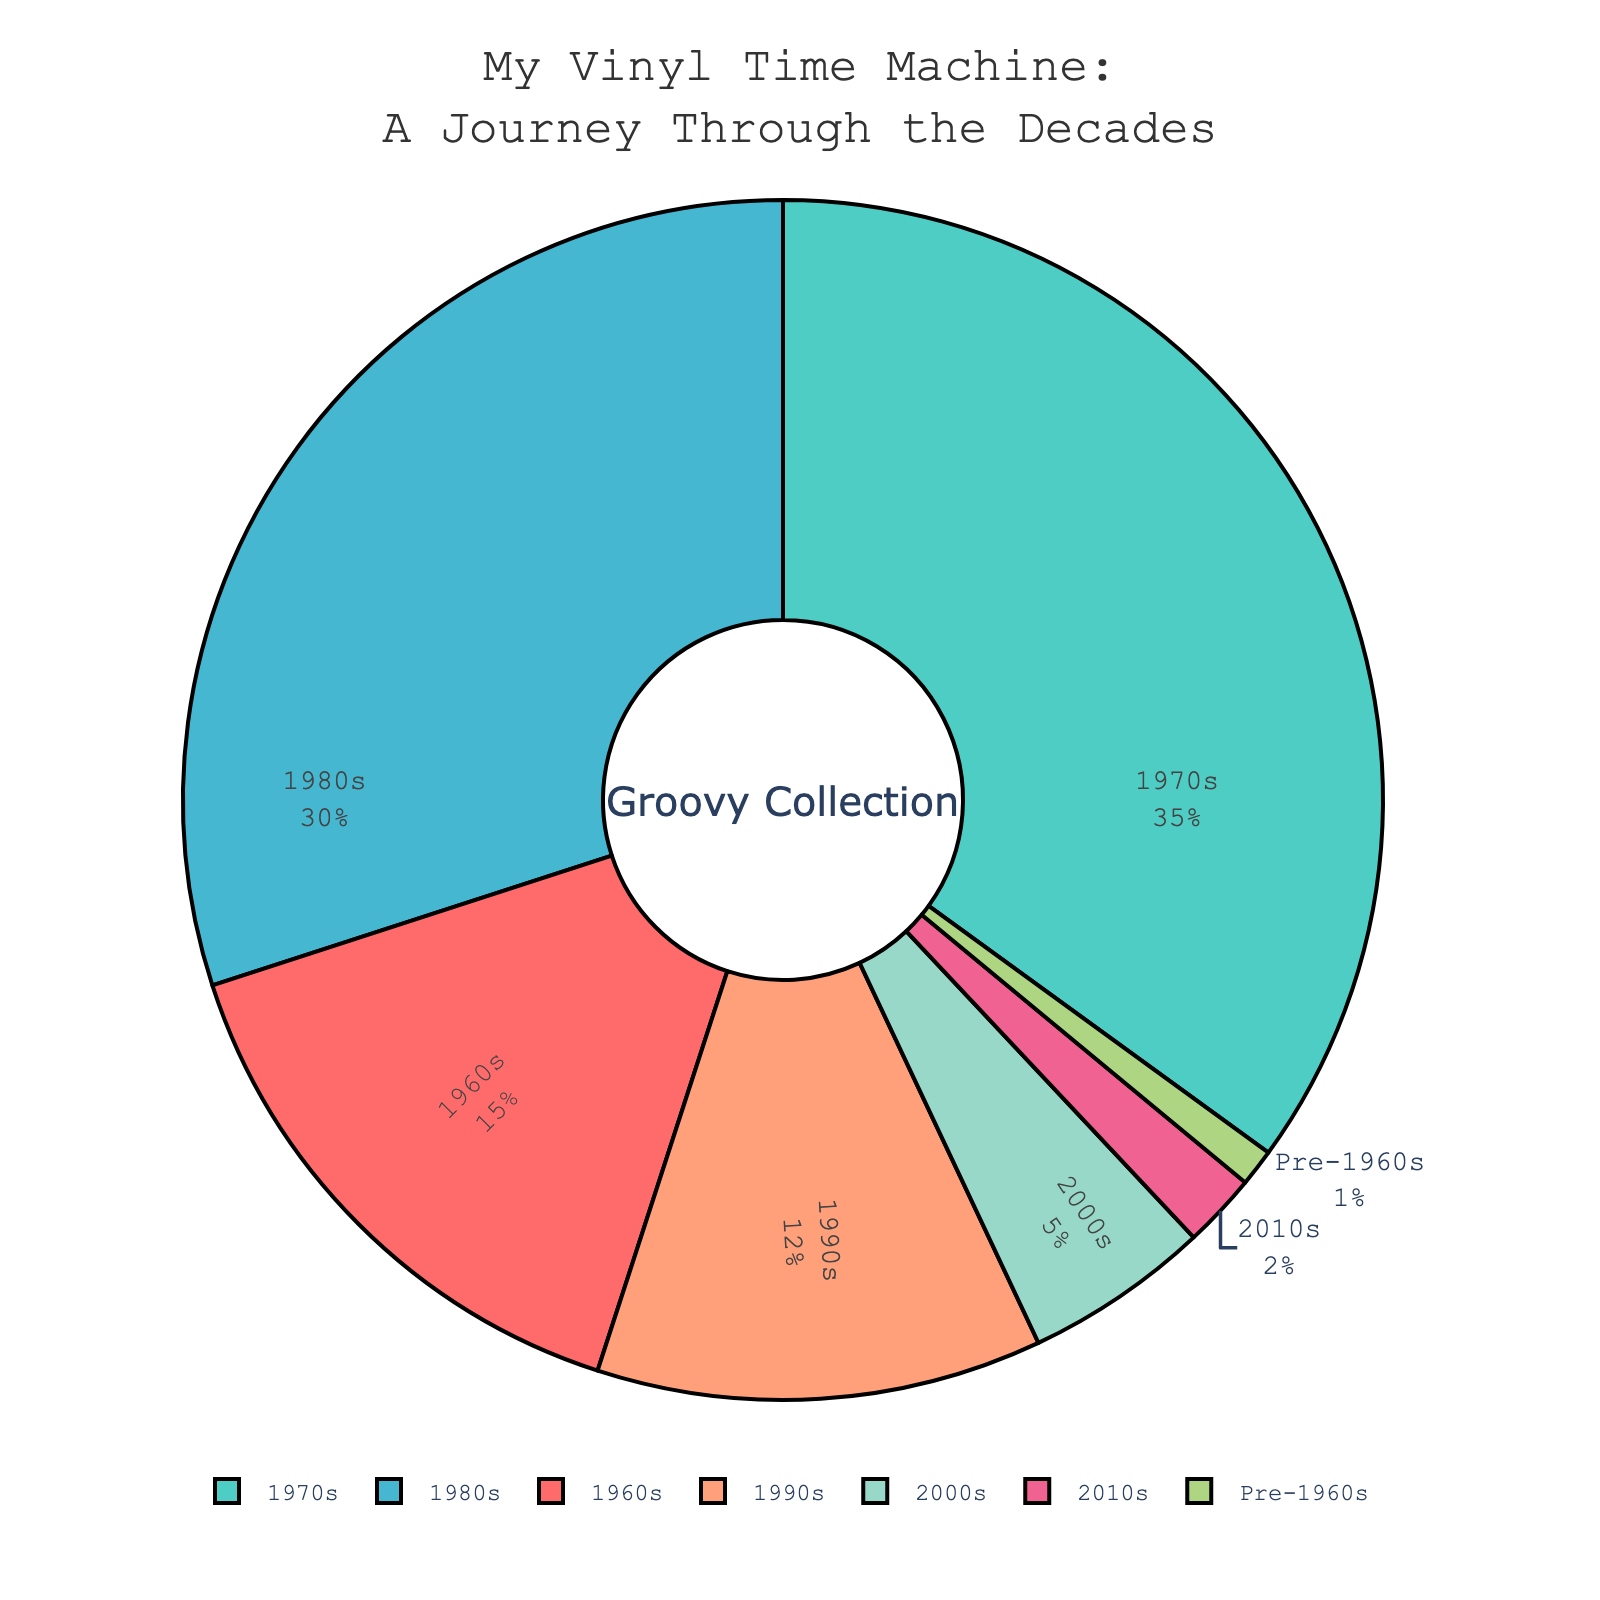Which decade has the largest percentage allocation in the collection? The pie chart shows that the 1970s has the largest slice, indicating the highest allocation.
Answer: 1970s What is the combined percentage of the collection for the 1980s and 1990s? The percentage for the 1980s is 30%, and for the 1990s is 12%. Adding these values gives 30% + 12% = 42%.
Answer: 42% How does the 1970s percentage compare to the 2000s percentage? The 1970s has 35%, and the 2000s has 5%. The 1970s has a significantly higher percentage.
Answer: 1970s is greater What is the smallest percentage allocation in the collection and which decade does it belong to? The smallest slice of the pie chart corresponds to a 1% allocation, which belongs to the Pre-1960s category.
Answer: 1%, Pre-1960s What is the total percentage of the collection from decades before the 1980s? Adding the percentages from the 1960s (15%), 1970s (35%), and Pre-1960s (1%) results in 15% + 35% + 1% = 51%.
Answer: 51% How many times greater is the 1970s allocation compared to the 2010s? The 1970s allocation is 35%, and the 2010s is 2%. The 1970s allocation is 35% / 2% = 17.5 times greater.
Answer: 17.5 times Which decade has a similar percentage to the 1960s? The 1980s percentage is 30%, which is the closest among the presented decades to the 15% of the 1960s.
Answer: 1980s What is the difference in percentage between the decade with the highest allocation and the decade with the lowest? The 1970s have the highest allocation at 35%, and the Pre-1960s have the lowest at 1%. The difference is 35% - 1% = 34%.
Answer: 34% What is the visual cue for identifying the overall largest decade in the collection? The largest decade can be identified by the largest slice of the pie chart, which is labeled 1970s with 35%.
Answer: Largest slice, 1970s How does the allocation in the 2000s and 2010s combined compare to the allocation in the 1990s? The combined allocation of the 2000s (5%) and 2010s (2%) is 5% + 2% = 7%, which is less than the 1990s allocation of 12%.
Answer: Less 